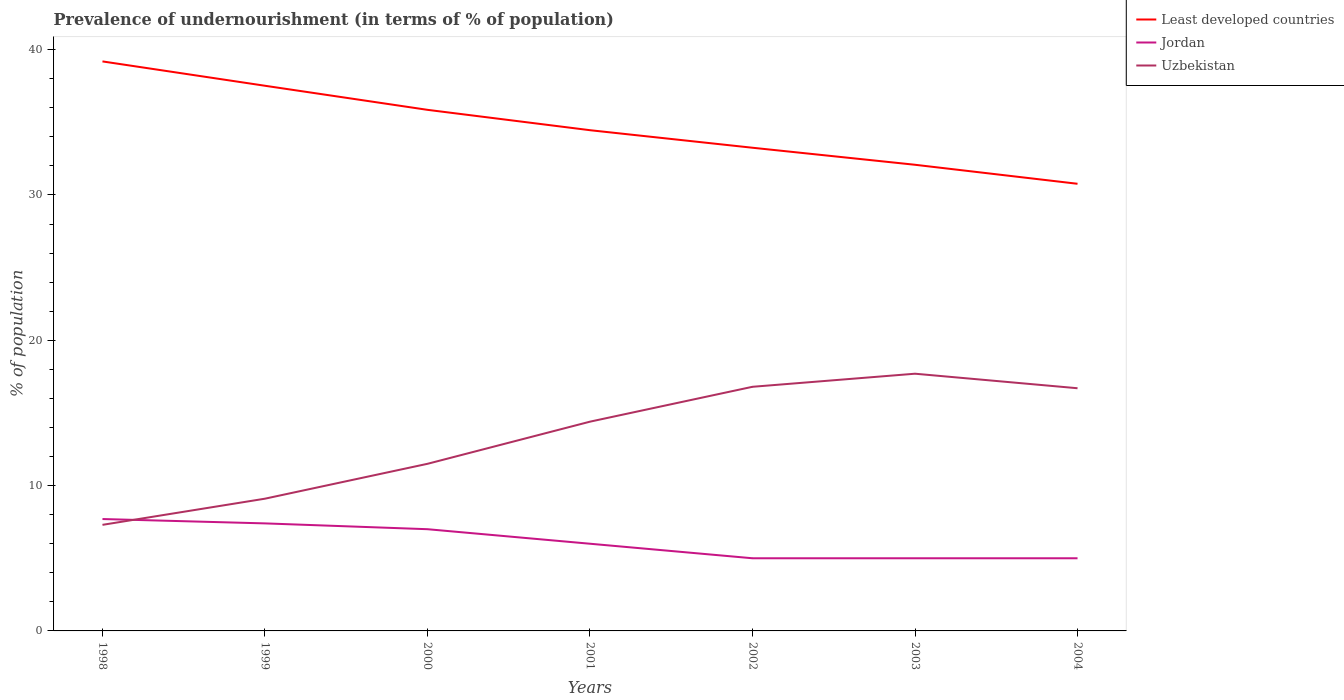Does the line corresponding to Jordan intersect with the line corresponding to Uzbekistan?
Ensure brevity in your answer.  Yes. Across all years, what is the maximum percentage of undernourished population in Least developed countries?
Ensure brevity in your answer.  30.77. In which year was the percentage of undernourished population in Least developed countries maximum?
Give a very brief answer. 2004. What is the difference between the highest and the second highest percentage of undernourished population in Uzbekistan?
Make the answer very short. 10.4. What is the difference between the highest and the lowest percentage of undernourished population in Uzbekistan?
Your response must be concise. 4. How many lines are there?
Provide a short and direct response. 3. What is the difference between two consecutive major ticks on the Y-axis?
Your response must be concise. 10. Are the values on the major ticks of Y-axis written in scientific E-notation?
Provide a short and direct response. No. Where does the legend appear in the graph?
Provide a succinct answer. Top right. How many legend labels are there?
Offer a very short reply. 3. How are the legend labels stacked?
Your response must be concise. Vertical. What is the title of the graph?
Make the answer very short. Prevalence of undernourishment (in terms of % of population). What is the label or title of the Y-axis?
Ensure brevity in your answer.  % of population. What is the % of population of Least developed countries in 1998?
Your response must be concise. 39.19. What is the % of population in Jordan in 1998?
Give a very brief answer. 7.7. What is the % of population of Uzbekistan in 1998?
Your response must be concise. 7.3. What is the % of population of Least developed countries in 1999?
Give a very brief answer. 37.52. What is the % of population of Jordan in 1999?
Provide a short and direct response. 7.4. What is the % of population of Uzbekistan in 1999?
Provide a succinct answer. 9.1. What is the % of population of Least developed countries in 2000?
Your response must be concise. 35.86. What is the % of population of Jordan in 2000?
Your answer should be compact. 7. What is the % of population of Uzbekistan in 2000?
Give a very brief answer. 11.5. What is the % of population in Least developed countries in 2001?
Keep it short and to the point. 34.46. What is the % of population of Uzbekistan in 2001?
Your response must be concise. 14.4. What is the % of population of Least developed countries in 2002?
Your answer should be compact. 33.25. What is the % of population of Jordan in 2002?
Provide a succinct answer. 5. What is the % of population in Least developed countries in 2003?
Give a very brief answer. 32.08. What is the % of population of Jordan in 2003?
Keep it short and to the point. 5. What is the % of population of Uzbekistan in 2003?
Provide a succinct answer. 17.7. What is the % of population of Least developed countries in 2004?
Offer a terse response. 30.77. What is the % of population of Uzbekistan in 2004?
Your response must be concise. 16.7. Across all years, what is the maximum % of population of Least developed countries?
Your answer should be compact. 39.19. Across all years, what is the maximum % of population of Jordan?
Offer a very short reply. 7.7. Across all years, what is the maximum % of population in Uzbekistan?
Keep it short and to the point. 17.7. Across all years, what is the minimum % of population of Least developed countries?
Give a very brief answer. 30.77. Across all years, what is the minimum % of population of Jordan?
Your answer should be very brief. 5. What is the total % of population of Least developed countries in the graph?
Your answer should be compact. 243.12. What is the total % of population in Jordan in the graph?
Ensure brevity in your answer.  43.1. What is the total % of population in Uzbekistan in the graph?
Give a very brief answer. 93.5. What is the difference between the % of population in Least developed countries in 1998 and that in 1999?
Your answer should be compact. 1.67. What is the difference between the % of population in Uzbekistan in 1998 and that in 1999?
Give a very brief answer. -1.8. What is the difference between the % of population in Least developed countries in 1998 and that in 2000?
Make the answer very short. 3.33. What is the difference between the % of population of Least developed countries in 1998 and that in 2001?
Offer a very short reply. 4.73. What is the difference between the % of population in Least developed countries in 1998 and that in 2002?
Offer a very short reply. 5.94. What is the difference between the % of population of Least developed countries in 1998 and that in 2003?
Keep it short and to the point. 7.11. What is the difference between the % of population in Jordan in 1998 and that in 2003?
Make the answer very short. 2.7. What is the difference between the % of population in Least developed countries in 1998 and that in 2004?
Your response must be concise. 8.42. What is the difference between the % of population in Jordan in 1998 and that in 2004?
Give a very brief answer. 2.7. What is the difference between the % of population in Least developed countries in 1999 and that in 2000?
Offer a terse response. 1.66. What is the difference between the % of population of Least developed countries in 1999 and that in 2001?
Your response must be concise. 3.06. What is the difference between the % of population of Jordan in 1999 and that in 2001?
Provide a short and direct response. 1.4. What is the difference between the % of population of Least developed countries in 1999 and that in 2002?
Ensure brevity in your answer.  4.27. What is the difference between the % of population of Least developed countries in 1999 and that in 2003?
Give a very brief answer. 5.44. What is the difference between the % of population in Least developed countries in 1999 and that in 2004?
Make the answer very short. 6.75. What is the difference between the % of population of Uzbekistan in 1999 and that in 2004?
Give a very brief answer. -7.6. What is the difference between the % of population of Least developed countries in 2000 and that in 2001?
Your answer should be very brief. 1.4. What is the difference between the % of population of Uzbekistan in 2000 and that in 2001?
Offer a terse response. -2.9. What is the difference between the % of population in Least developed countries in 2000 and that in 2002?
Give a very brief answer. 2.61. What is the difference between the % of population of Jordan in 2000 and that in 2002?
Provide a succinct answer. 2. What is the difference between the % of population of Least developed countries in 2000 and that in 2003?
Ensure brevity in your answer.  3.78. What is the difference between the % of population in Least developed countries in 2000 and that in 2004?
Make the answer very short. 5.09. What is the difference between the % of population of Jordan in 2000 and that in 2004?
Provide a short and direct response. 2. What is the difference between the % of population in Uzbekistan in 2000 and that in 2004?
Provide a short and direct response. -5.2. What is the difference between the % of population of Least developed countries in 2001 and that in 2002?
Your response must be concise. 1.21. What is the difference between the % of population of Jordan in 2001 and that in 2002?
Give a very brief answer. 1. What is the difference between the % of population in Least developed countries in 2001 and that in 2003?
Keep it short and to the point. 2.38. What is the difference between the % of population in Least developed countries in 2001 and that in 2004?
Your response must be concise. 3.69. What is the difference between the % of population of Jordan in 2001 and that in 2004?
Give a very brief answer. 1. What is the difference between the % of population of Least developed countries in 2002 and that in 2003?
Your answer should be compact. 1.17. What is the difference between the % of population in Jordan in 2002 and that in 2003?
Keep it short and to the point. 0. What is the difference between the % of population of Least developed countries in 2002 and that in 2004?
Provide a succinct answer. 2.48. What is the difference between the % of population in Least developed countries in 2003 and that in 2004?
Provide a short and direct response. 1.31. What is the difference between the % of population in Least developed countries in 1998 and the % of population in Jordan in 1999?
Keep it short and to the point. 31.79. What is the difference between the % of population of Least developed countries in 1998 and the % of population of Uzbekistan in 1999?
Offer a terse response. 30.09. What is the difference between the % of population in Least developed countries in 1998 and the % of population in Jordan in 2000?
Provide a succinct answer. 32.19. What is the difference between the % of population in Least developed countries in 1998 and the % of population in Uzbekistan in 2000?
Offer a terse response. 27.69. What is the difference between the % of population in Jordan in 1998 and the % of population in Uzbekistan in 2000?
Offer a terse response. -3.8. What is the difference between the % of population in Least developed countries in 1998 and the % of population in Jordan in 2001?
Give a very brief answer. 33.19. What is the difference between the % of population of Least developed countries in 1998 and the % of population of Uzbekistan in 2001?
Provide a succinct answer. 24.79. What is the difference between the % of population of Jordan in 1998 and the % of population of Uzbekistan in 2001?
Make the answer very short. -6.7. What is the difference between the % of population in Least developed countries in 1998 and the % of population in Jordan in 2002?
Provide a succinct answer. 34.19. What is the difference between the % of population in Least developed countries in 1998 and the % of population in Uzbekistan in 2002?
Your answer should be compact. 22.39. What is the difference between the % of population of Jordan in 1998 and the % of population of Uzbekistan in 2002?
Give a very brief answer. -9.1. What is the difference between the % of population in Least developed countries in 1998 and the % of population in Jordan in 2003?
Give a very brief answer. 34.19. What is the difference between the % of population of Least developed countries in 1998 and the % of population of Uzbekistan in 2003?
Provide a short and direct response. 21.49. What is the difference between the % of population of Jordan in 1998 and the % of population of Uzbekistan in 2003?
Your answer should be very brief. -10. What is the difference between the % of population of Least developed countries in 1998 and the % of population of Jordan in 2004?
Ensure brevity in your answer.  34.19. What is the difference between the % of population in Least developed countries in 1998 and the % of population in Uzbekistan in 2004?
Your answer should be compact. 22.49. What is the difference between the % of population of Least developed countries in 1999 and the % of population of Jordan in 2000?
Make the answer very short. 30.52. What is the difference between the % of population in Least developed countries in 1999 and the % of population in Uzbekistan in 2000?
Your answer should be compact. 26.02. What is the difference between the % of population in Jordan in 1999 and the % of population in Uzbekistan in 2000?
Offer a very short reply. -4.1. What is the difference between the % of population in Least developed countries in 1999 and the % of population in Jordan in 2001?
Your response must be concise. 31.52. What is the difference between the % of population in Least developed countries in 1999 and the % of population in Uzbekistan in 2001?
Give a very brief answer. 23.12. What is the difference between the % of population of Jordan in 1999 and the % of population of Uzbekistan in 2001?
Your answer should be compact. -7. What is the difference between the % of population of Least developed countries in 1999 and the % of population of Jordan in 2002?
Ensure brevity in your answer.  32.52. What is the difference between the % of population of Least developed countries in 1999 and the % of population of Uzbekistan in 2002?
Provide a succinct answer. 20.72. What is the difference between the % of population in Least developed countries in 1999 and the % of population in Jordan in 2003?
Offer a very short reply. 32.52. What is the difference between the % of population in Least developed countries in 1999 and the % of population in Uzbekistan in 2003?
Ensure brevity in your answer.  19.82. What is the difference between the % of population of Least developed countries in 1999 and the % of population of Jordan in 2004?
Make the answer very short. 32.52. What is the difference between the % of population of Least developed countries in 1999 and the % of population of Uzbekistan in 2004?
Provide a succinct answer. 20.82. What is the difference between the % of population of Least developed countries in 2000 and the % of population of Jordan in 2001?
Provide a short and direct response. 29.86. What is the difference between the % of population of Least developed countries in 2000 and the % of population of Uzbekistan in 2001?
Provide a short and direct response. 21.46. What is the difference between the % of population in Least developed countries in 2000 and the % of population in Jordan in 2002?
Ensure brevity in your answer.  30.86. What is the difference between the % of population of Least developed countries in 2000 and the % of population of Uzbekistan in 2002?
Your answer should be compact. 19.06. What is the difference between the % of population of Jordan in 2000 and the % of population of Uzbekistan in 2002?
Give a very brief answer. -9.8. What is the difference between the % of population in Least developed countries in 2000 and the % of population in Jordan in 2003?
Make the answer very short. 30.86. What is the difference between the % of population of Least developed countries in 2000 and the % of population of Uzbekistan in 2003?
Offer a very short reply. 18.16. What is the difference between the % of population in Jordan in 2000 and the % of population in Uzbekistan in 2003?
Ensure brevity in your answer.  -10.7. What is the difference between the % of population of Least developed countries in 2000 and the % of population of Jordan in 2004?
Keep it short and to the point. 30.86. What is the difference between the % of population in Least developed countries in 2000 and the % of population in Uzbekistan in 2004?
Keep it short and to the point. 19.16. What is the difference between the % of population in Least developed countries in 2001 and the % of population in Jordan in 2002?
Keep it short and to the point. 29.46. What is the difference between the % of population in Least developed countries in 2001 and the % of population in Uzbekistan in 2002?
Offer a very short reply. 17.66. What is the difference between the % of population in Least developed countries in 2001 and the % of population in Jordan in 2003?
Give a very brief answer. 29.46. What is the difference between the % of population of Least developed countries in 2001 and the % of population of Uzbekistan in 2003?
Offer a terse response. 16.76. What is the difference between the % of population in Least developed countries in 2001 and the % of population in Jordan in 2004?
Give a very brief answer. 29.46. What is the difference between the % of population of Least developed countries in 2001 and the % of population of Uzbekistan in 2004?
Keep it short and to the point. 17.76. What is the difference between the % of population in Least developed countries in 2002 and the % of population in Jordan in 2003?
Your answer should be very brief. 28.25. What is the difference between the % of population of Least developed countries in 2002 and the % of population of Uzbekistan in 2003?
Offer a terse response. 15.55. What is the difference between the % of population of Least developed countries in 2002 and the % of population of Jordan in 2004?
Offer a terse response. 28.25. What is the difference between the % of population of Least developed countries in 2002 and the % of population of Uzbekistan in 2004?
Your response must be concise. 16.55. What is the difference between the % of population in Jordan in 2002 and the % of population in Uzbekistan in 2004?
Make the answer very short. -11.7. What is the difference between the % of population of Least developed countries in 2003 and the % of population of Jordan in 2004?
Keep it short and to the point. 27.08. What is the difference between the % of population in Least developed countries in 2003 and the % of population in Uzbekistan in 2004?
Ensure brevity in your answer.  15.38. What is the average % of population of Least developed countries per year?
Make the answer very short. 34.73. What is the average % of population of Jordan per year?
Your response must be concise. 6.16. What is the average % of population of Uzbekistan per year?
Give a very brief answer. 13.36. In the year 1998, what is the difference between the % of population of Least developed countries and % of population of Jordan?
Offer a very short reply. 31.49. In the year 1998, what is the difference between the % of population of Least developed countries and % of population of Uzbekistan?
Provide a succinct answer. 31.89. In the year 1999, what is the difference between the % of population in Least developed countries and % of population in Jordan?
Your response must be concise. 30.12. In the year 1999, what is the difference between the % of population in Least developed countries and % of population in Uzbekistan?
Your answer should be very brief. 28.42. In the year 2000, what is the difference between the % of population in Least developed countries and % of population in Jordan?
Ensure brevity in your answer.  28.86. In the year 2000, what is the difference between the % of population of Least developed countries and % of population of Uzbekistan?
Your response must be concise. 24.36. In the year 2001, what is the difference between the % of population of Least developed countries and % of population of Jordan?
Offer a terse response. 28.46. In the year 2001, what is the difference between the % of population in Least developed countries and % of population in Uzbekistan?
Make the answer very short. 20.06. In the year 2001, what is the difference between the % of population in Jordan and % of population in Uzbekistan?
Provide a short and direct response. -8.4. In the year 2002, what is the difference between the % of population in Least developed countries and % of population in Jordan?
Your response must be concise. 28.25. In the year 2002, what is the difference between the % of population in Least developed countries and % of population in Uzbekistan?
Offer a very short reply. 16.45. In the year 2002, what is the difference between the % of population in Jordan and % of population in Uzbekistan?
Your answer should be compact. -11.8. In the year 2003, what is the difference between the % of population of Least developed countries and % of population of Jordan?
Your answer should be compact. 27.08. In the year 2003, what is the difference between the % of population of Least developed countries and % of population of Uzbekistan?
Provide a succinct answer. 14.38. In the year 2003, what is the difference between the % of population in Jordan and % of population in Uzbekistan?
Your answer should be very brief. -12.7. In the year 2004, what is the difference between the % of population in Least developed countries and % of population in Jordan?
Give a very brief answer. 25.77. In the year 2004, what is the difference between the % of population of Least developed countries and % of population of Uzbekistan?
Provide a short and direct response. 14.07. What is the ratio of the % of population in Least developed countries in 1998 to that in 1999?
Provide a succinct answer. 1.04. What is the ratio of the % of population of Jordan in 1998 to that in 1999?
Your answer should be compact. 1.04. What is the ratio of the % of population of Uzbekistan in 1998 to that in 1999?
Offer a terse response. 0.8. What is the ratio of the % of population in Least developed countries in 1998 to that in 2000?
Make the answer very short. 1.09. What is the ratio of the % of population in Jordan in 1998 to that in 2000?
Ensure brevity in your answer.  1.1. What is the ratio of the % of population of Uzbekistan in 1998 to that in 2000?
Give a very brief answer. 0.63. What is the ratio of the % of population of Least developed countries in 1998 to that in 2001?
Offer a very short reply. 1.14. What is the ratio of the % of population in Jordan in 1998 to that in 2001?
Make the answer very short. 1.28. What is the ratio of the % of population in Uzbekistan in 1998 to that in 2001?
Ensure brevity in your answer.  0.51. What is the ratio of the % of population in Least developed countries in 1998 to that in 2002?
Provide a short and direct response. 1.18. What is the ratio of the % of population of Jordan in 1998 to that in 2002?
Keep it short and to the point. 1.54. What is the ratio of the % of population in Uzbekistan in 1998 to that in 2002?
Your answer should be very brief. 0.43. What is the ratio of the % of population in Least developed countries in 1998 to that in 2003?
Your response must be concise. 1.22. What is the ratio of the % of population of Jordan in 1998 to that in 2003?
Your answer should be compact. 1.54. What is the ratio of the % of population in Uzbekistan in 1998 to that in 2003?
Provide a succinct answer. 0.41. What is the ratio of the % of population in Least developed countries in 1998 to that in 2004?
Offer a terse response. 1.27. What is the ratio of the % of population of Jordan in 1998 to that in 2004?
Make the answer very short. 1.54. What is the ratio of the % of population in Uzbekistan in 1998 to that in 2004?
Offer a very short reply. 0.44. What is the ratio of the % of population of Least developed countries in 1999 to that in 2000?
Ensure brevity in your answer.  1.05. What is the ratio of the % of population in Jordan in 1999 to that in 2000?
Your response must be concise. 1.06. What is the ratio of the % of population in Uzbekistan in 1999 to that in 2000?
Provide a short and direct response. 0.79. What is the ratio of the % of population in Least developed countries in 1999 to that in 2001?
Provide a short and direct response. 1.09. What is the ratio of the % of population of Jordan in 1999 to that in 2001?
Ensure brevity in your answer.  1.23. What is the ratio of the % of population of Uzbekistan in 1999 to that in 2001?
Make the answer very short. 0.63. What is the ratio of the % of population in Least developed countries in 1999 to that in 2002?
Offer a very short reply. 1.13. What is the ratio of the % of population in Jordan in 1999 to that in 2002?
Offer a terse response. 1.48. What is the ratio of the % of population of Uzbekistan in 1999 to that in 2002?
Give a very brief answer. 0.54. What is the ratio of the % of population in Least developed countries in 1999 to that in 2003?
Keep it short and to the point. 1.17. What is the ratio of the % of population of Jordan in 1999 to that in 2003?
Your answer should be compact. 1.48. What is the ratio of the % of population in Uzbekistan in 1999 to that in 2003?
Keep it short and to the point. 0.51. What is the ratio of the % of population in Least developed countries in 1999 to that in 2004?
Your response must be concise. 1.22. What is the ratio of the % of population of Jordan in 1999 to that in 2004?
Ensure brevity in your answer.  1.48. What is the ratio of the % of population of Uzbekistan in 1999 to that in 2004?
Make the answer very short. 0.54. What is the ratio of the % of population of Least developed countries in 2000 to that in 2001?
Your response must be concise. 1.04. What is the ratio of the % of population of Uzbekistan in 2000 to that in 2001?
Your response must be concise. 0.8. What is the ratio of the % of population of Least developed countries in 2000 to that in 2002?
Your response must be concise. 1.08. What is the ratio of the % of population of Uzbekistan in 2000 to that in 2002?
Provide a short and direct response. 0.68. What is the ratio of the % of population of Least developed countries in 2000 to that in 2003?
Your answer should be very brief. 1.12. What is the ratio of the % of population in Jordan in 2000 to that in 2003?
Provide a succinct answer. 1.4. What is the ratio of the % of population in Uzbekistan in 2000 to that in 2003?
Keep it short and to the point. 0.65. What is the ratio of the % of population of Least developed countries in 2000 to that in 2004?
Offer a very short reply. 1.17. What is the ratio of the % of population in Jordan in 2000 to that in 2004?
Your answer should be compact. 1.4. What is the ratio of the % of population in Uzbekistan in 2000 to that in 2004?
Your answer should be very brief. 0.69. What is the ratio of the % of population of Least developed countries in 2001 to that in 2002?
Keep it short and to the point. 1.04. What is the ratio of the % of population of Jordan in 2001 to that in 2002?
Your answer should be compact. 1.2. What is the ratio of the % of population in Uzbekistan in 2001 to that in 2002?
Make the answer very short. 0.86. What is the ratio of the % of population in Least developed countries in 2001 to that in 2003?
Give a very brief answer. 1.07. What is the ratio of the % of population of Jordan in 2001 to that in 2003?
Offer a very short reply. 1.2. What is the ratio of the % of population in Uzbekistan in 2001 to that in 2003?
Provide a succinct answer. 0.81. What is the ratio of the % of population of Least developed countries in 2001 to that in 2004?
Offer a terse response. 1.12. What is the ratio of the % of population in Jordan in 2001 to that in 2004?
Your response must be concise. 1.2. What is the ratio of the % of population in Uzbekistan in 2001 to that in 2004?
Give a very brief answer. 0.86. What is the ratio of the % of population in Least developed countries in 2002 to that in 2003?
Your answer should be compact. 1.04. What is the ratio of the % of population of Jordan in 2002 to that in 2003?
Your response must be concise. 1. What is the ratio of the % of population in Uzbekistan in 2002 to that in 2003?
Provide a succinct answer. 0.95. What is the ratio of the % of population in Least developed countries in 2002 to that in 2004?
Offer a terse response. 1.08. What is the ratio of the % of population of Jordan in 2002 to that in 2004?
Provide a succinct answer. 1. What is the ratio of the % of population in Least developed countries in 2003 to that in 2004?
Your answer should be compact. 1.04. What is the ratio of the % of population of Uzbekistan in 2003 to that in 2004?
Offer a terse response. 1.06. What is the difference between the highest and the second highest % of population in Least developed countries?
Offer a terse response. 1.67. What is the difference between the highest and the second highest % of population of Jordan?
Keep it short and to the point. 0.3. What is the difference between the highest and the second highest % of population in Uzbekistan?
Offer a terse response. 0.9. What is the difference between the highest and the lowest % of population of Least developed countries?
Ensure brevity in your answer.  8.42. What is the difference between the highest and the lowest % of population in Jordan?
Provide a short and direct response. 2.7. What is the difference between the highest and the lowest % of population in Uzbekistan?
Offer a very short reply. 10.4. 